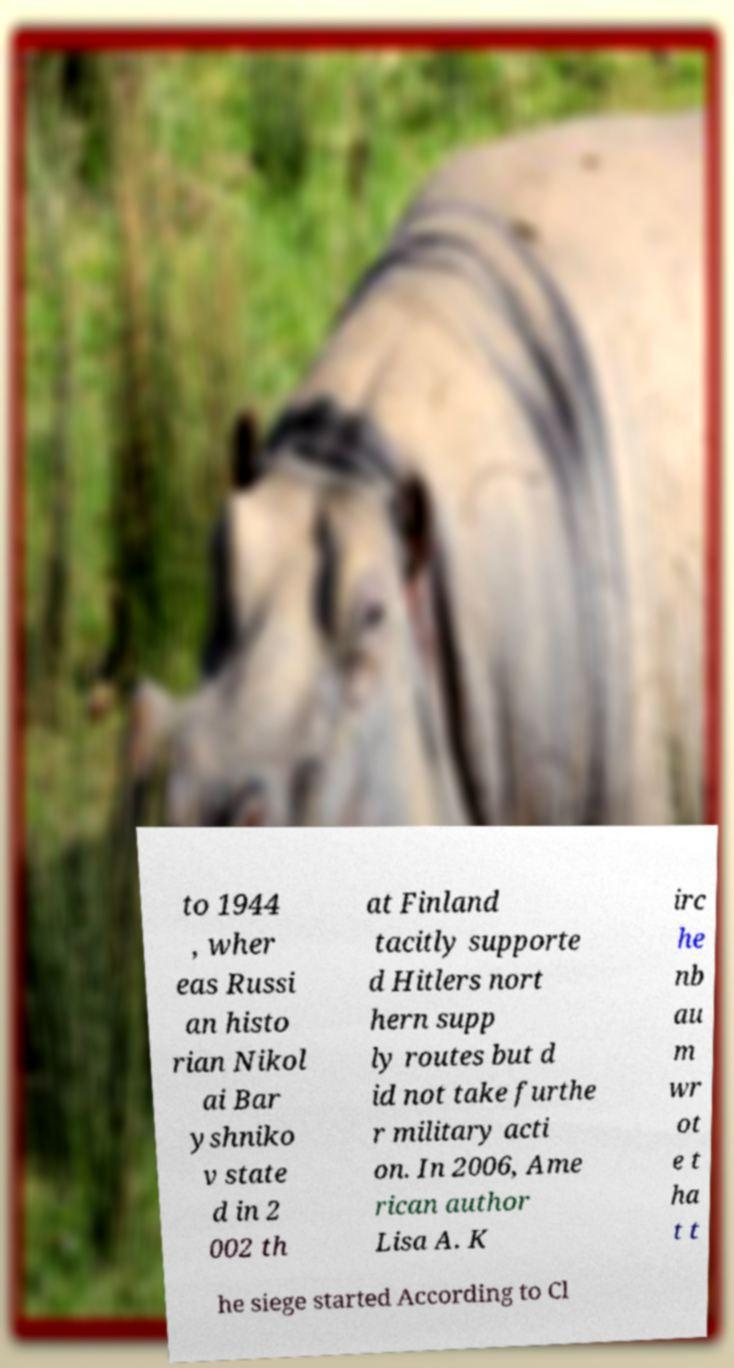Please identify and transcribe the text found in this image. to 1944 , wher eas Russi an histo rian Nikol ai Bar yshniko v state d in 2 002 th at Finland tacitly supporte d Hitlers nort hern supp ly routes but d id not take furthe r military acti on. In 2006, Ame rican author Lisa A. K irc he nb au m wr ot e t ha t t he siege started According to Cl 